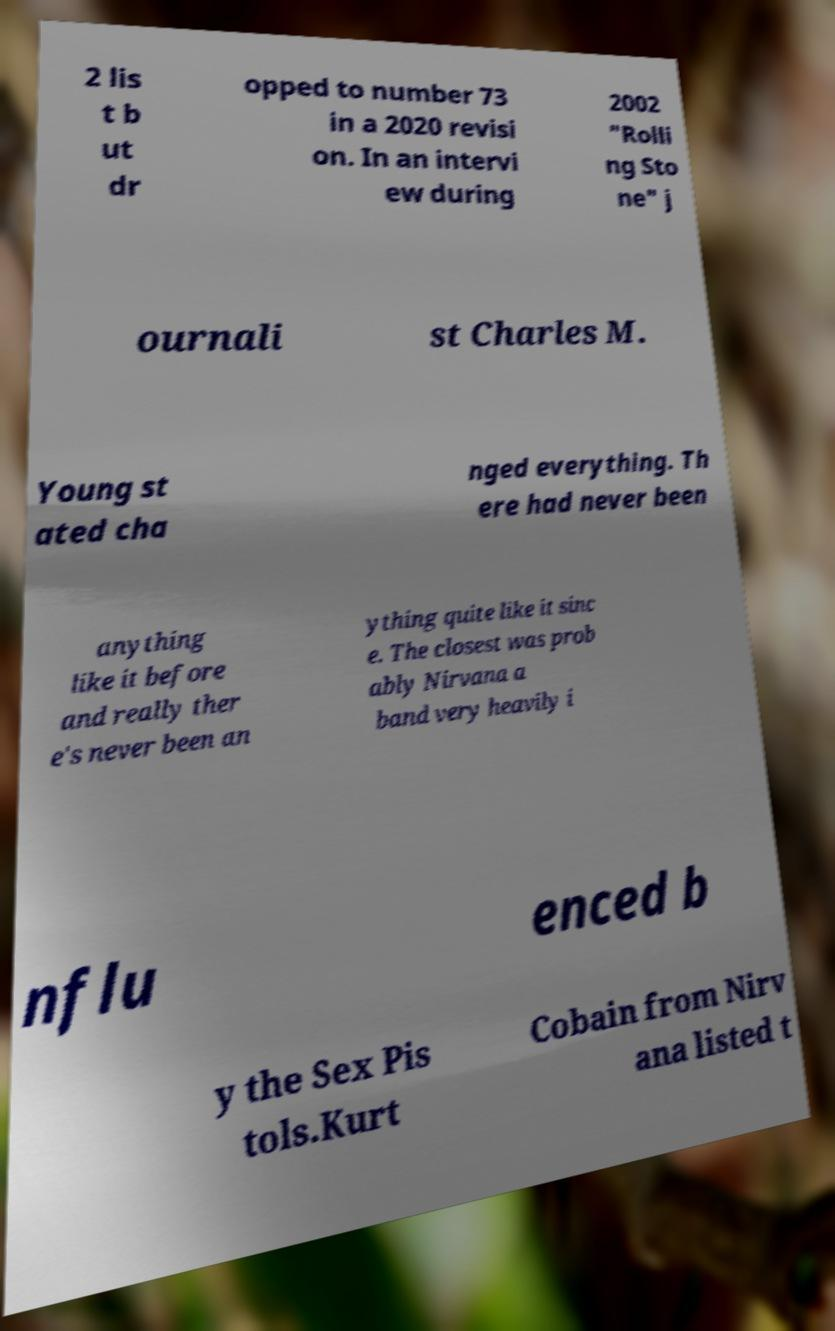Can you accurately transcribe the text from the provided image for me? 2 lis t b ut dr opped to number 73 in a 2020 revisi on. In an intervi ew during 2002 "Rolli ng Sto ne" j ournali st Charles M. Young st ated cha nged everything. Th ere had never been anything like it before and really ther e's never been an ything quite like it sinc e. The closest was prob ably Nirvana a band very heavily i nflu enced b y the Sex Pis tols.Kurt Cobain from Nirv ana listed t 